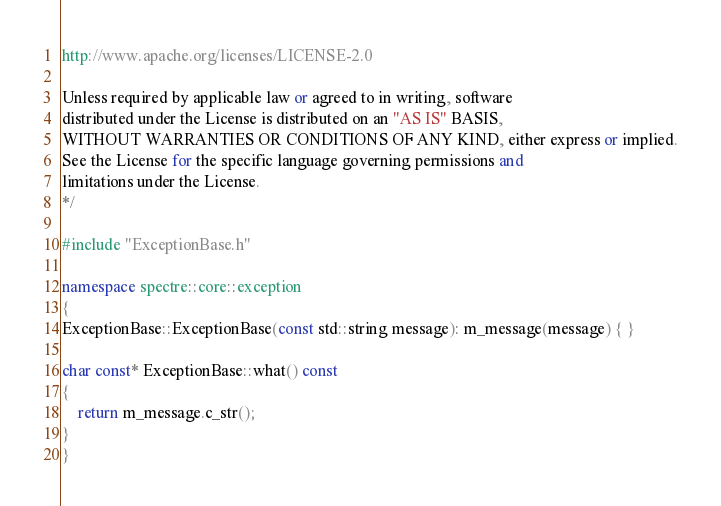Convert code to text. <code><loc_0><loc_0><loc_500><loc_500><_C++_>
http://www.apache.org/licenses/LICENSE-2.0

Unless required by applicable law or agreed to in writing, software
distributed under the License is distributed on an "AS IS" BASIS,
WITHOUT WARRANTIES OR CONDITIONS OF ANY KIND, either express or implied.
See the License for the specific language governing permissions and
limitations under the License.
*/

#include "ExceptionBase.h"

namespace spectre::core::exception
{
ExceptionBase::ExceptionBase(const std::string message): m_message(message) { }

char const* ExceptionBase::what() const
{
    return m_message.c_str();
}
}
</code> 